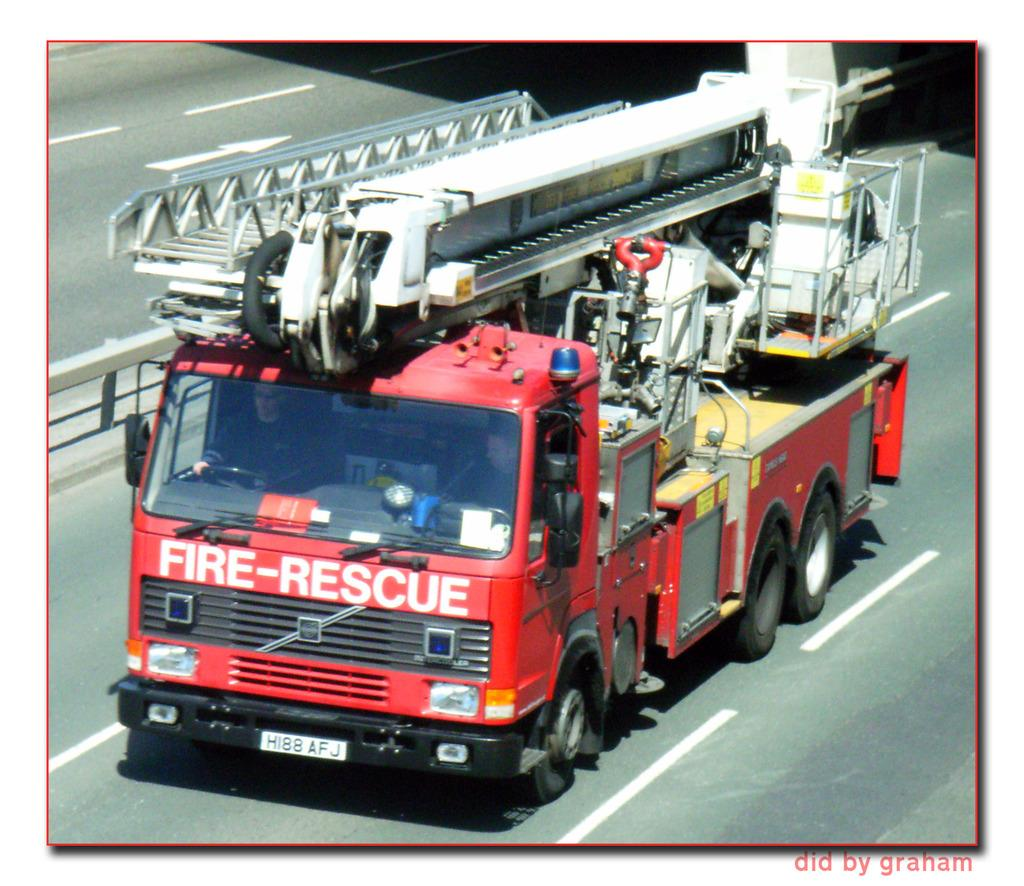What is the person in the image doing? There is a person driving a fire engine in the image. Where is the fire engine located? The fire engine is on the road. What can be seen near the road in the image? There is a railing visible in the image. What type of quilt is being used to cover the stove in the image? There is no quilt or stove present in the image; it features a person driving a fire engine on the road with a railing nearby. 